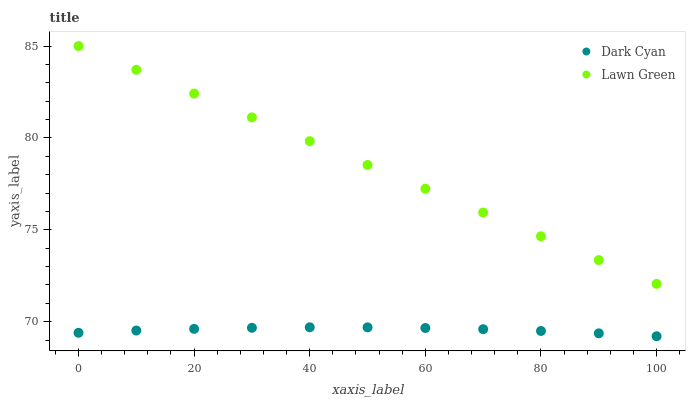Does Dark Cyan have the minimum area under the curve?
Answer yes or no. Yes. Does Lawn Green have the maximum area under the curve?
Answer yes or no. Yes. Does Lawn Green have the minimum area under the curve?
Answer yes or no. No. Is Lawn Green the smoothest?
Answer yes or no. Yes. Is Dark Cyan the roughest?
Answer yes or no. Yes. Is Lawn Green the roughest?
Answer yes or no. No. Does Dark Cyan have the lowest value?
Answer yes or no. Yes. Does Lawn Green have the lowest value?
Answer yes or no. No. Does Lawn Green have the highest value?
Answer yes or no. Yes. Is Dark Cyan less than Lawn Green?
Answer yes or no. Yes. Is Lawn Green greater than Dark Cyan?
Answer yes or no. Yes. Does Dark Cyan intersect Lawn Green?
Answer yes or no. No. 